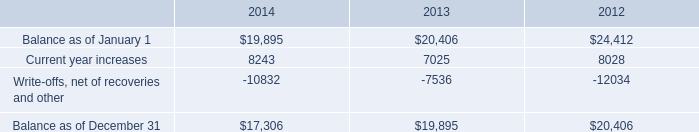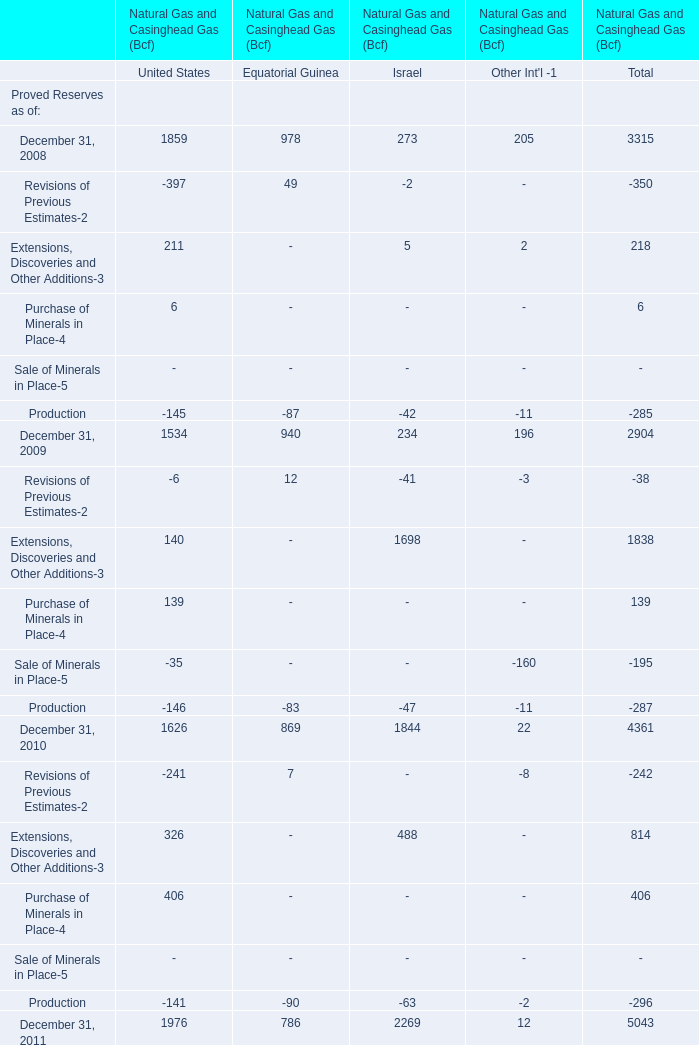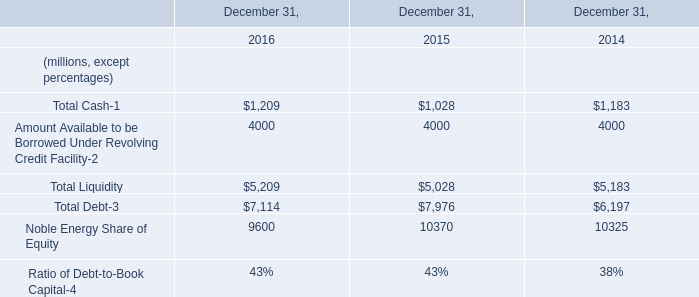What is the sum of Balance as of December 31 of 2012, and Noble Energy Share of Equity of December 31, 2016 ? 
Computations: (20406.0 + 9600.0)
Answer: 30006.0. 